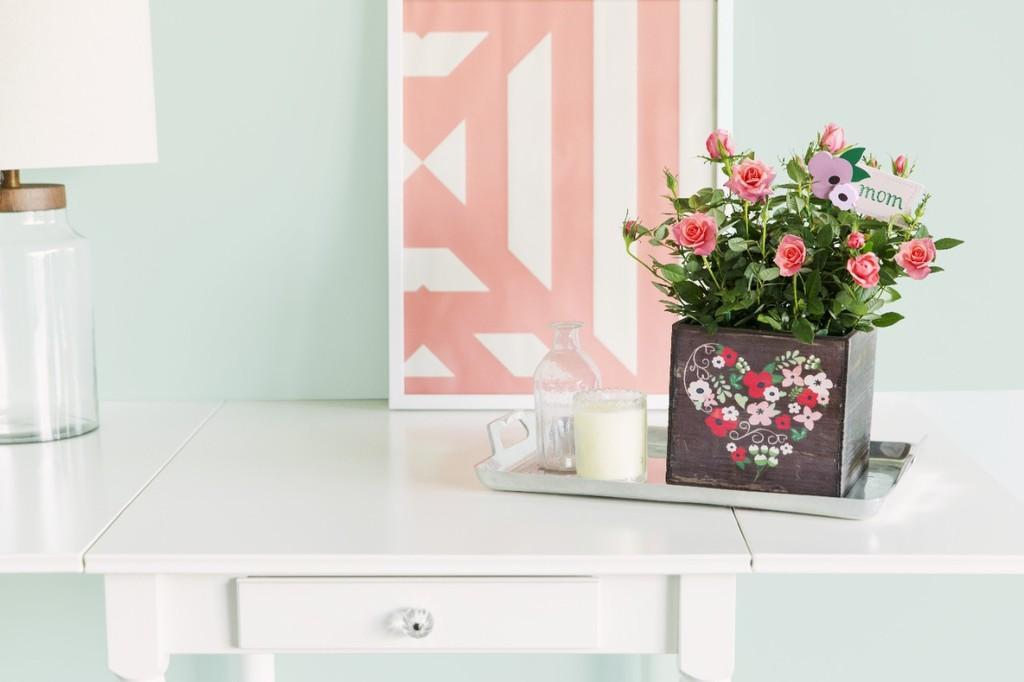How would you summarize this image in a sentence or two? On this table there is a picture, tray, bottle, candle, plant and lantern lamp. 